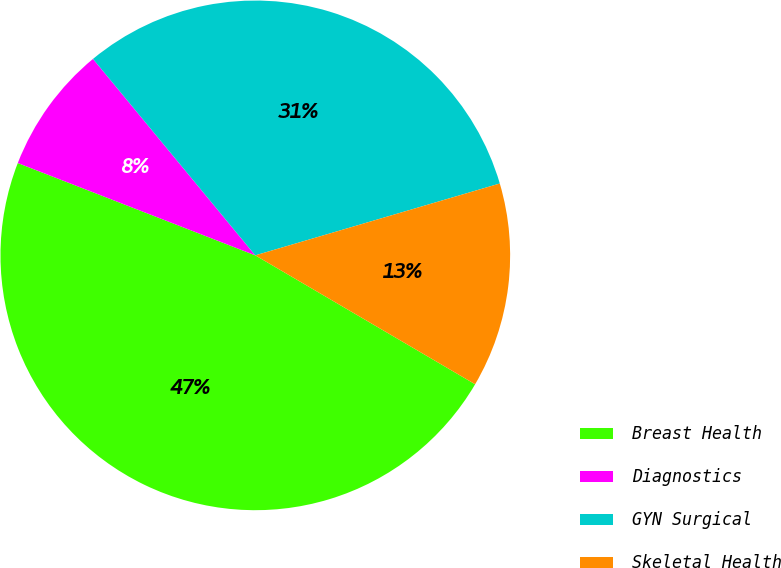Convert chart to OTSL. <chart><loc_0><loc_0><loc_500><loc_500><pie_chart><fcel>Breast Health<fcel>Diagnostics<fcel>GYN Surgical<fcel>Skeletal Health<nl><fcel>47.46%<fcel>8.11%<fcel>31.44%<fcel>12.99%<nl></chart> 